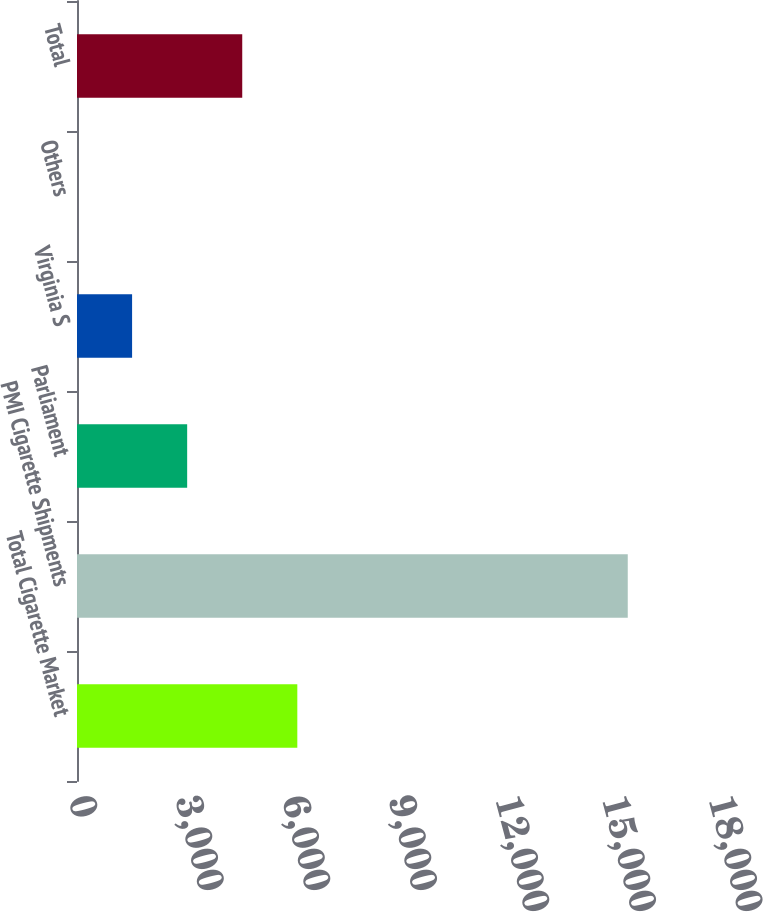<chart> <loc_0><loc_0><loc_500><loc_500><bar_chart><fcel>Total Cigarette Market<fcel>PMI Cigarette Shipments<fcel>Parliament<fcel>Virginia S<fcel>Others<fcel>Total<nl><fcel>6196.3<fcel>15490<fcel>3098.4<fcel>1549.45<fcel>0.5<fcel>4647.35<nl></chart> 